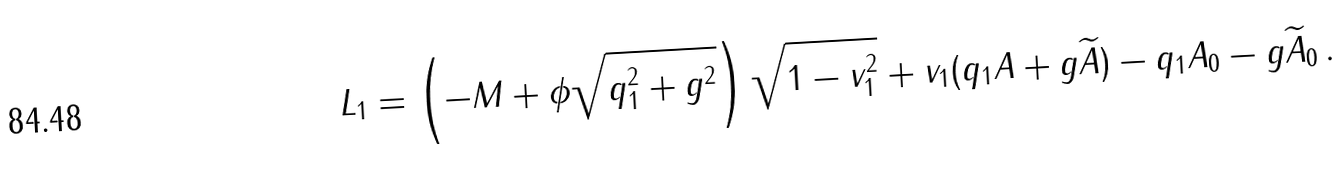Convert formula to latex. <formula><loc_0><loc_0><loc_500><loc_500>L _ { 1 } = \left ( - M + \phi { \sqrt { q _ { 1 } ^ { 2 } + g ^ { 2 } } } \right ) \sqrt { 1 - v _ { 1 } ^ { 2 } } + { v } _ { 1 } ( q _ { 1 } { A } + g { \widetilde { A } } ) - q _ { 1 } A _ { 0 } - g { \widetilde { A } } _ { 0 } \, .</formula> 